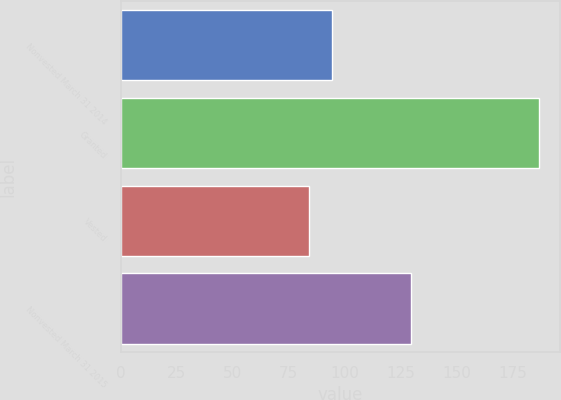<chart> <loc_0><loc_0><loc_500><loc_500><bar_chart><fcel>Nonvested March 31 2014<fcel>Granted<fcel>Vested<fcel>Nonvested March 31 2015<nl><fcel>94.56<fcel>187.03<fcel>84.28<fcel>129.57<nl></chart> 